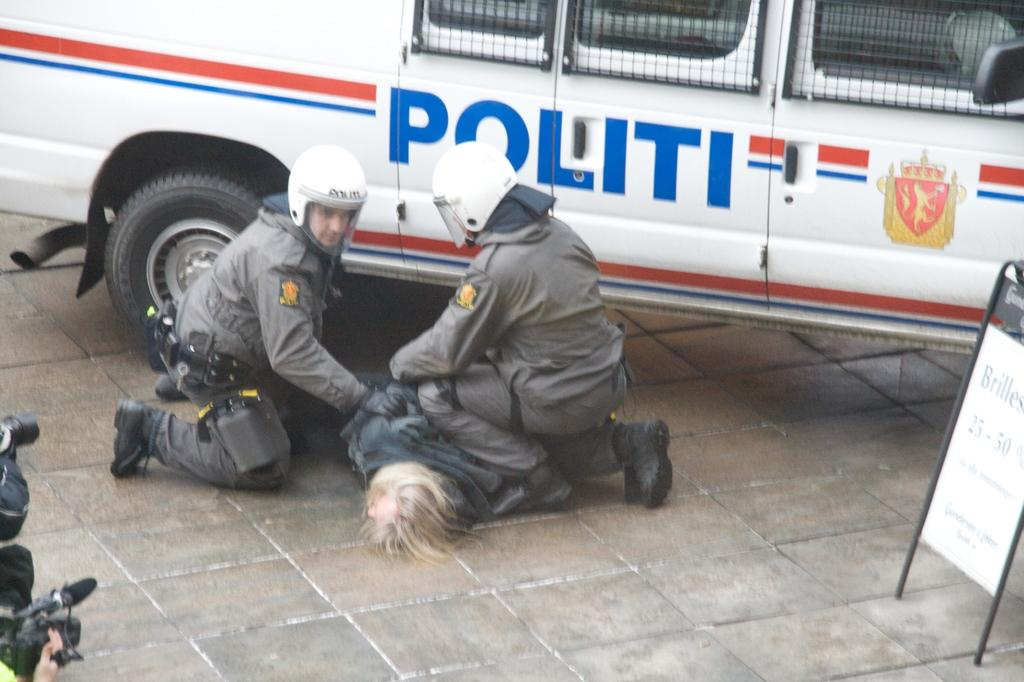<image>
Summarize the visual content of the image. a van with the word 'politi' on the side of it in blue 